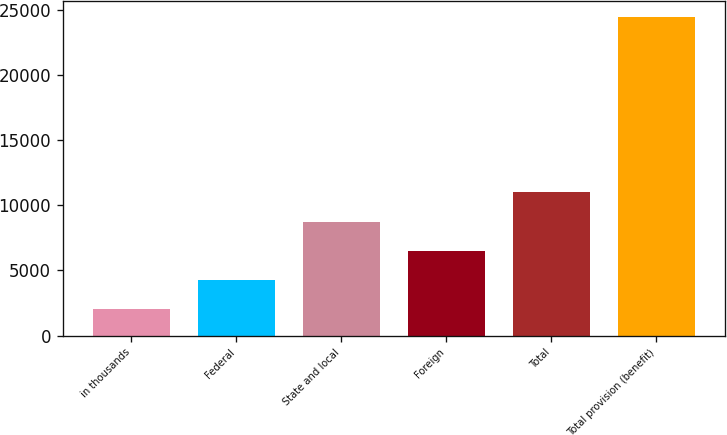Convert chart to OTSL. <chart><loc_0><loc_0><loc_500><loc_500><bar_chart><fcel>in thousands<fcel>Federal<fcel>State and local<fcel>Foreign<fcel>Total<fcel>Total provision (benefit)<nl><fcel>2013<fcel>4257.6<fcel>8746.8<fcel>6502.2<fcel>10991.4<fcel>24459<nl></chart> 